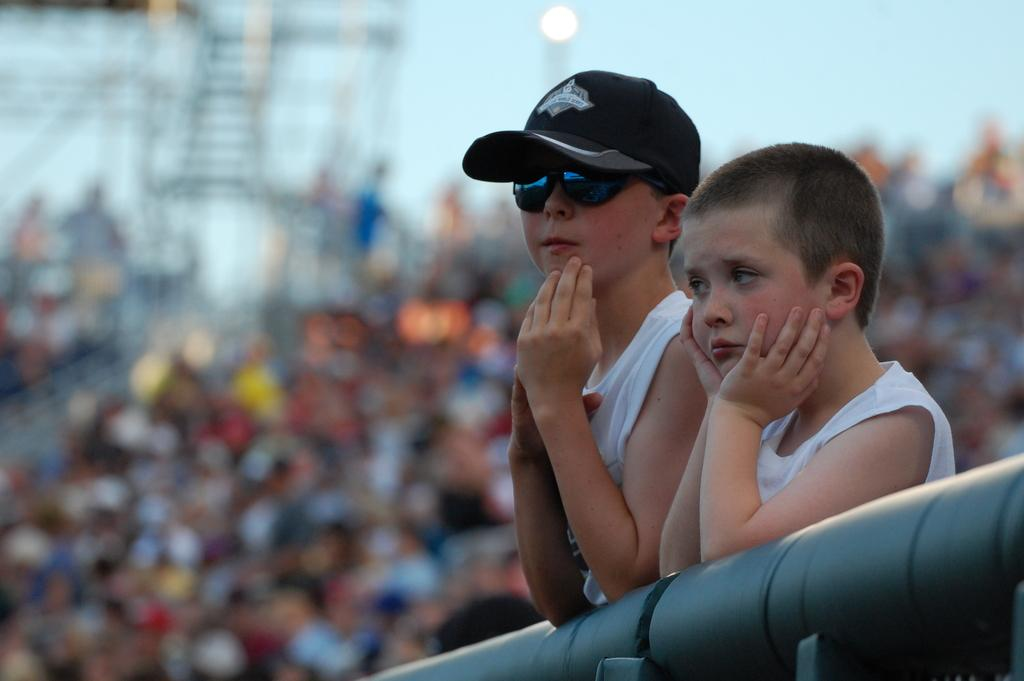How many people are visible in the image? There are two people standing in the image. What are the people wearing? Both people are wearing white shirts. What can be seen in the background of the image? There is a group of people sitting in the background. What is the color of the sky in the image? The sky appears to be white in color. What type of plants can be seen growing in the notebook in the image? There is no notebook or plants present in the image. 